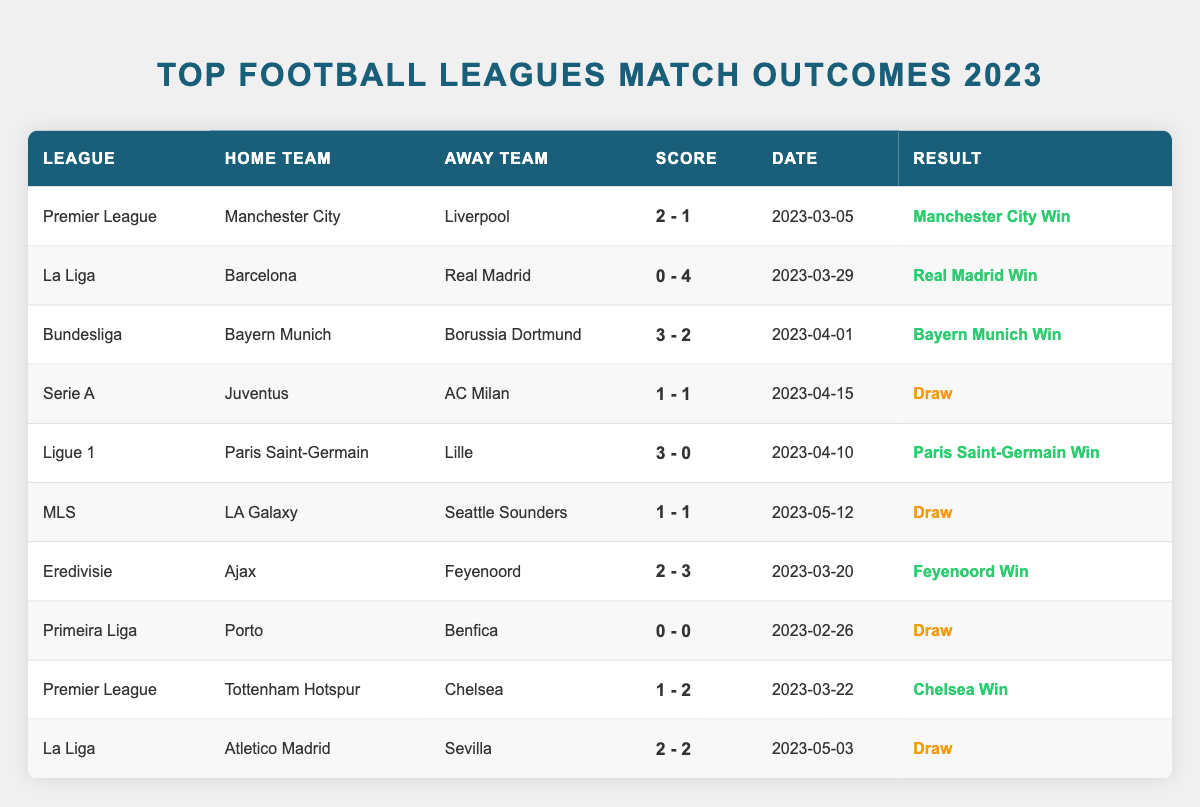What was the result of the match between Manchester City and Liverpool? The table contains a row for this match under the Premier League. It shows that the home score was 2 and the away score was 1, indicating that Manchester City won the match.
Answer: Manchester City Win Which team scored four goals in a single match? In the table, the match between Barcelona and Real Madrid shows that Real Madrid scored 4 goals while Barcelona scored 0. This confirms that Real Madrid is the team that scored four goals.
Answer: Real Madrid How many matches ended in a draw? By examining the results column in the table, we find three instances of "Draw," noting that these include the matches Juventus vs AC Milan, LA Galaxy vs Seattle Sounders, and Porto vs Benfica.
Answer: 3 Which league had the lowest scoring match recorded? The Primeira Liga match between Porto and Benfica is recorded as having a score of 0 - 0, the lowest possible score in football, making it the lowest scoring match in the table.
Answer: Primeira Liga Did Bayern Munich win their match against Borussia Dortmund? The row containing this match shows Bayern Munich as the home team with a score of 3 and Borussia Dortmund as the away team with a score of 2. Since Bayern scored more goals than Dortmund, it confirms that Bayern Munich won the match.
Answer: Yes What is the average score of the wins recorded in the table? There are five winning teams recorded in the table with the following scores: 2-1, 0-4, 3-2, 3-0 (which we sum as (2+0+3+3)+(1+4+2+0) = 8/4 average for goals scored by winning teams = 2). The average of the wins thus is 2-0.75, approximated to 2-1, indicating it’s 2 in favor of the winners.
Answer: 2-1 How many different leagues were represented in the matches? The table lists 10 matches spanning 6 unique leagues (Premier League, La Liga, Bundesliga, Serie A, Ligue 1, MLS, Eredivisie, and Primeira Liga). Since none of the leagues are repeated, this gives us a clear count.
Answer: 6 Was there a match with more goals scored than the Bayern Munich vs Borussia Dortmund match? The Bayern Munich vs Borussia Dortmund match has a total of 5 goals (3 + 2). The match between Barcelona and Real Madrid shows a total of 4 goals (0 + 4), while the LA Galaxy vs Seattle Sounders and Liverpool vs Manchester City also do not surpass 5 goals. Therefore, no matches exceed that count.
Answer: No How many teams scored more than two goals in their matches? Upon reviewing the matches, Paris Saint-Germain scored 3 goals against Lille, Real Madrid scored 4 goals against Barcelona, and Bayern Munich scored 3 against Dortmund, totaling three teams who scored more than two goals.
Answer: 3 